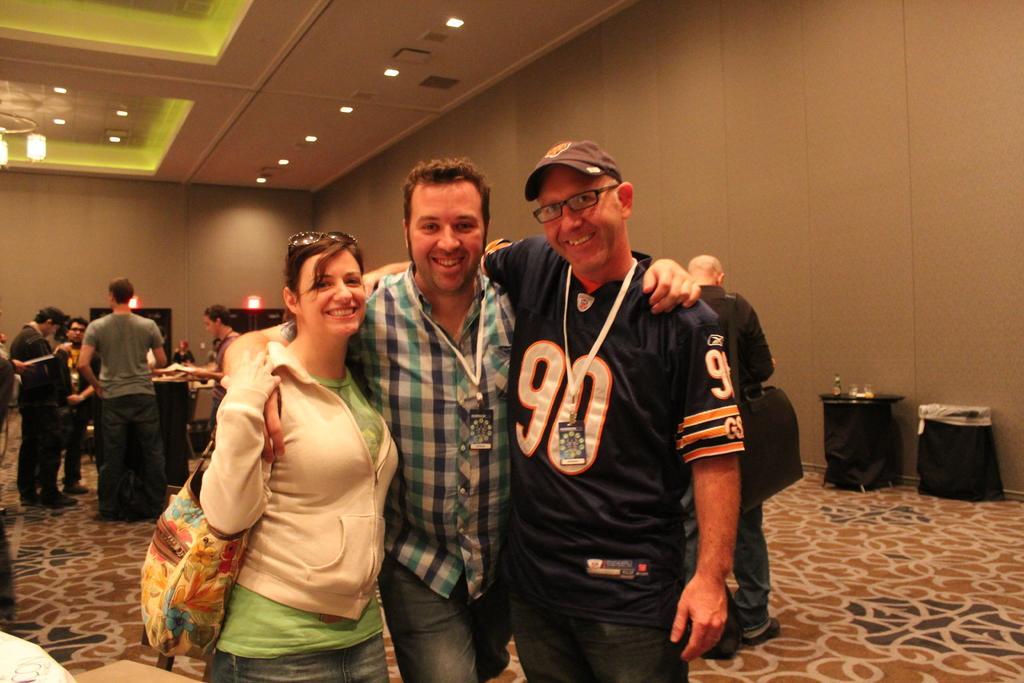Can you describe this image briefly? In front of the image there are three people having a smile on their faces. Behind them there are a few other people standing. On the right side of the image there are some objects. On the left side of the image there is a table. On top of it there is some object. In the background of the image there are doors. There are display boards on the wall. On top of the image there are lights. 